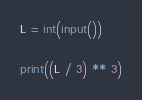<code> <loc_0><loc_0><loc_500><loc_500><_Python_>L = int(input())

print((L / 3) ** 3)
</code> 